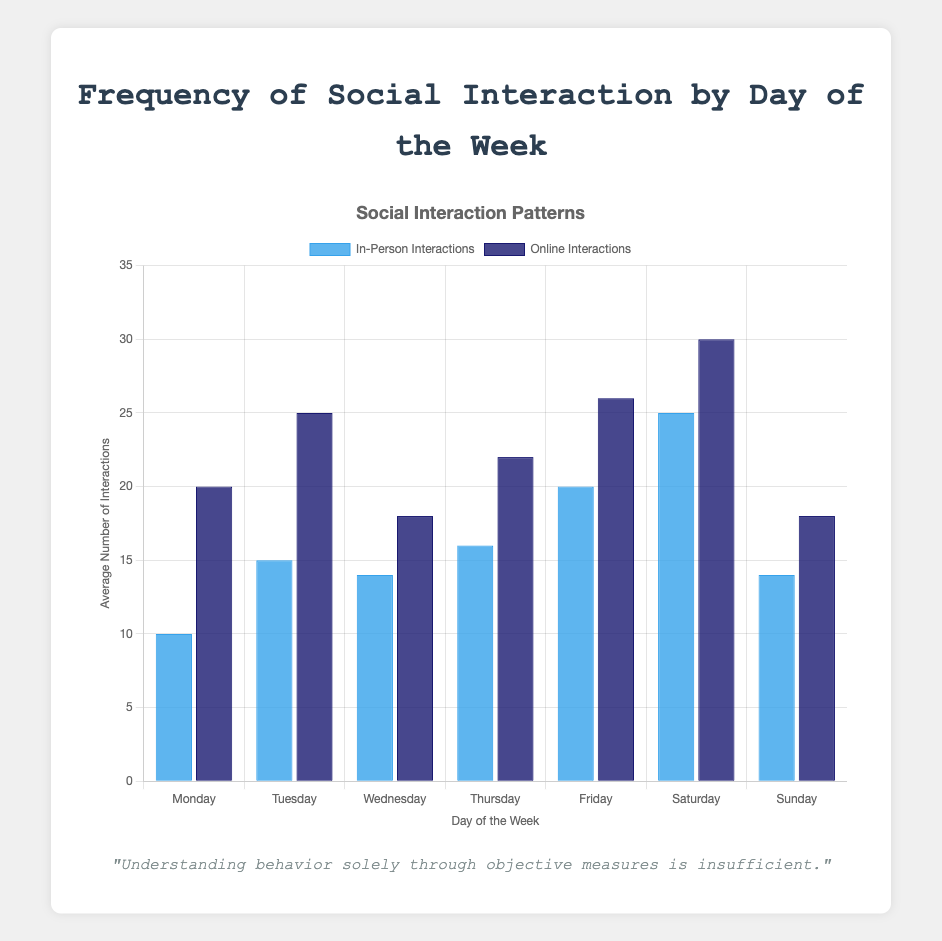What is the average number of in-person interactions on weekdays (Monday to Friday)? To find the average number of in-person interactions on weekdays, sum the values for Monday to Friday and divide by 5. (10 + 15 + 14 + 16 + 20) = 75. Then, 75 / 5 = 15
Answer: 15 Comparing Saturday and Sunday, which day has a higher average of online interactions? On Saturday, the average of online interactions is 30, while on Sunday it is 18. Since 30 > 18, Saturday has a higher average of online interactions.
Answer: Saturday What is the total number of social interactions (both in-person and online) on Friday? To find the total, sum the in-person and online interactions on Friday. (20 in-person + 26 online) = 46 interactions.
Answer: 46 Which mode of interaction (in-person or online) has the highest average on any single day, and what is that value? Compare all the daily averages for both in-person and online interactions. The highest average is 30 for online interactions on Saturday.
Answer: Online on Saturday, 30 Is there any day where the average in-person interactions are equal to the average online interactions? Examine each day to see if any have matching averages for in-person and online interactions. No day has equal averages for both modes of interaction.
Answer: No On which day is the difference between online and in-person interactions the smallest? Find the absolute differences between online and in-person interactions for each day and identify the smallest one. The differences are: Monday (10), Tuesday (10), Wednesday (4), Thursday (6), Friday (6), Saturday (5), Sunday (4). The smallest is 4, which occurs on Wednesday and Sunday.
Answer: Wednesday and Sunday What is the highest number of in-person interactions throughout the week? Look at the in-person interaction averages for each day and identify the highest value. The highest is 25 on Saturday.
Answer: 25 By how much do the total online interactions on Sunday exceed the total in-person interactions on Sunday? Subtract the in-person interactions from the online interactions on Sunday. (18 - 14) = 4
Answer: 4 On which day does the difference between online and in-person interactions show the greatest increase compared to the previous day? Calculate the day-over-day differences and find the day with the greatest increase. This computation requires examining each succeeding day and comparing. The largest increase in differences is from Friday (6) to Saturday (5) to a difference of 11.
Answer: Saturday 